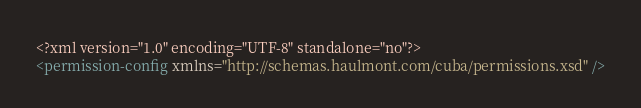<code> <loc_0><loc_0><loc_500><loc_500><_XML_><?xml version="1.0" encoding="UTF-8" standalone="no"?>
<permission-config xmlns="http://schemas.haulmont.com/cuba/permissions.xsd" />
</code> 